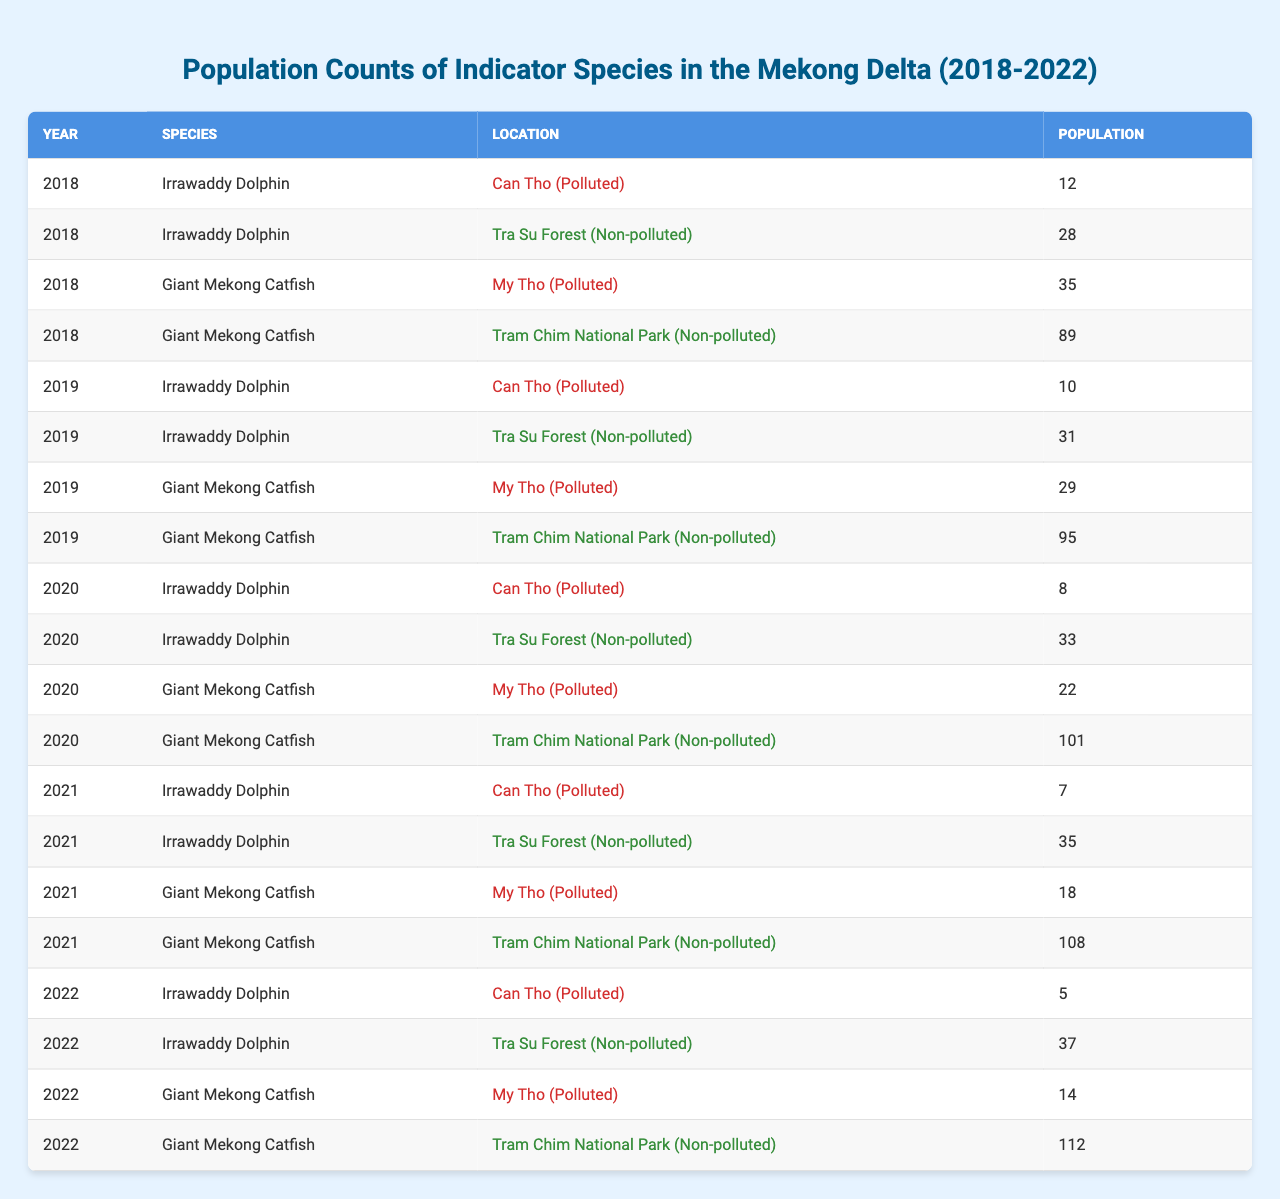What was the population of Irrawaddy Dolphins in Can Tho in 2020? The table shows that in 2020, the population of Irrawaddy Dolphins in Can Tho (Polluted) was 8.
Answer: 8 What is the total population of Giant Mekong Catfish in Tram Chim National Park from 2018 to 2022? The populations for 2018 (89), 2019 (95), 2020 (101), 2021 (108), and 2022 (112) need to be summed up: 89 + 95 + 101 + 108 + 112 = 505.
Answer: 505 Did the population of Irrawaddy Dolphins in Tra Su Forest (Non-polluted) decrease from 2019 to 2020? In 2019, the population was 31, and in 2020, it increased to 33. Therefore, the population did not decrease.
Answer: No What was the largest difference in population counts of Irrawaddy Dolphins between polluted and non-polluted areas in 2018? In 2018, the population in Can Tho (Polluted) was 12, and in Tra Su Forest (Non-polluted) it was 28. The difference is 28 - 12 = 16.
Answer: 16 How did the population of Giant Mekong Catfish in My Tho (Polluted) change from 2018 to 2022? In 2018, the population was 35, and it decreased to 14 in 2022. The change is 35 - 14 = 21.
Answer: Decreased by 21 Is the overall trend for Irrawaddy Dolphins in Can Tho (Polluted) a decrease from 2018 to 2022? The populations over the years are: 12 (2018), 10 (2019), 8 (2020), 7 (2021), and 5 (2022). Each year shows a consistent decrease. Therefore, the trend is a decrease.
Answer: Yes What percentage of the Irrawaddy Dolphin population in Tra Su Forest (Non-polluted) in 2022 is compared to 2018? The populations are 37 in 2022 and 28 in 2018, so the change is (37 - 28)/28 * 100% = 32.14%.
Answer: 32.14% Which species showed the least population in polluted areas in 2022? The table indicates that in 2022, the Giant Mekong Catfish was 14 and Irrawaddy Dolphins were 5 in polluted areas. Therefore, the Irrawaddy Dolphins showed the least population.
Answer: Irrawaddy Dolphins What was the average population of Irrawaddy Dolphins in non-polluted areas from 2018 to 2022? The populations are 28 (2018), 31 (2019), 33 (2020), 35 (2021), and 37 (2022). The sum is 28 + 31 + 33 + 35 + 37 = 164, and there are 5 data points, thus the average is 164 / 5 = 32.8.
Answer: 32.8 